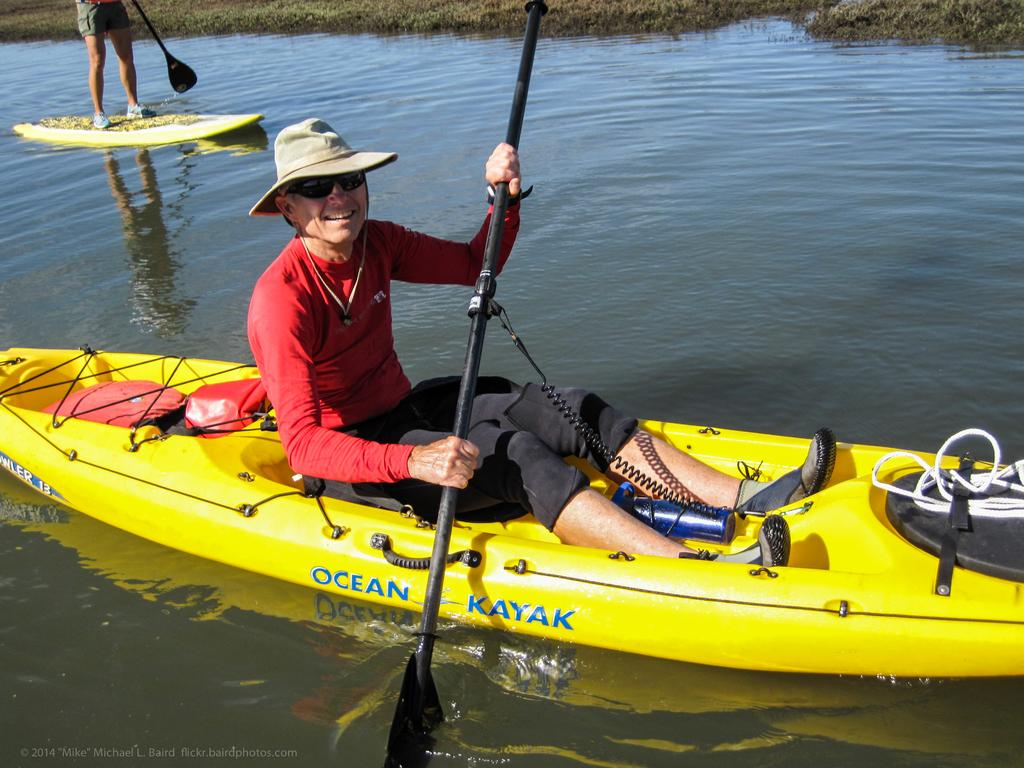What is the person doing in the image? There is a person sitting on a boat in the image. Where is the boat located? The boat is in the river. Is there anyone else on the boat? Yes, there is another person standing on the boat. How many tickets are needed for the crowd to enter the boat in the image? There is no crowd present in the image, and therefore no tickets are needed for entry. 